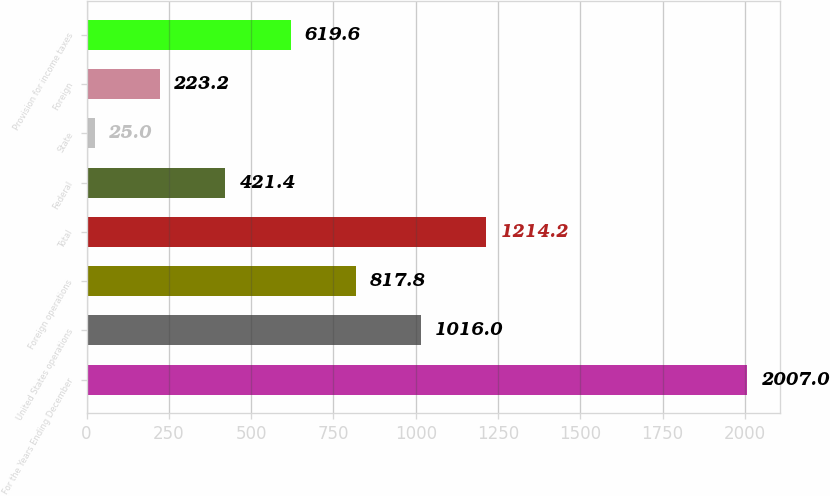<chart> <loc_0><loc_0><loc_500><loc_500><bar_chart><fcel>For the Years Ending December<fcel>United States operations<fcel>Foreign operations<fcel>Total<fcel>Federal<fcel>State<fcel>Foreign<fcel>Provision for income taxes<nl><fcel>2007<fcel>1016<fcel>817.8<fcel>1214.2<fcel>421.4<fcel>25<fcel>223.2<fcel>619.6<nl></chart> 